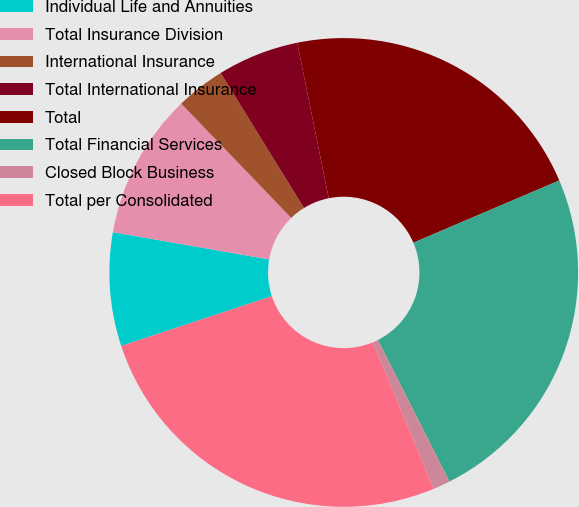Convert chart. <chart><loc_0><loc_0><loc_500><loc_500><pie_chart><fcel>Individual Life and Annuities<fcel>Total Insurance Division<fcel>International Insurance<fcel>Total International Insurance<fcel>Total<fcel>Total Financial Services<fcel>Closed Block Business<fcel>Total per Consolidated<nl><fcel>7.83%<fcel>10.05%<fcel>3.4%<fcel>5.62%<fcel>21.76%<fcel>23.97%<fcel>1.18%<fcel>26.19%<nl></chart> 